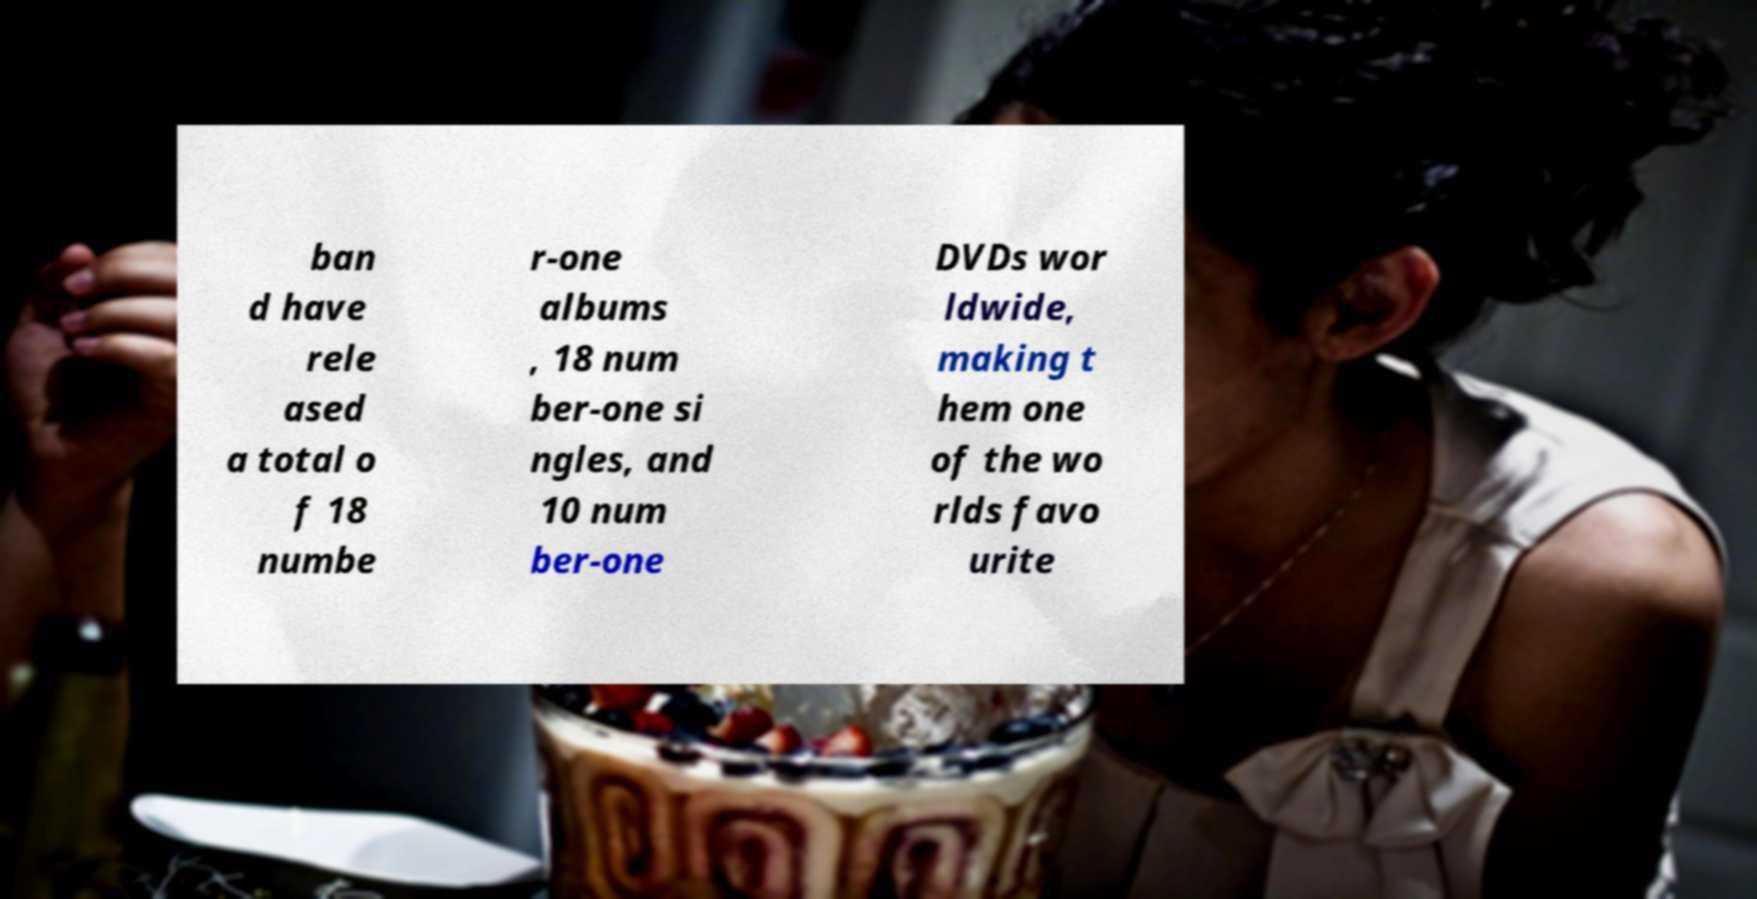Can you read and provide the text displayed in the image?This photo seems to have some interesting text. Can you extract and type it out for me? ban d have rele ased a total o f 18 numbe r-one albums , 18 num ber-one si ngles, and 10 num ber-one DVDs wor ldwide, making t hem one of the wo rlds favo urite 